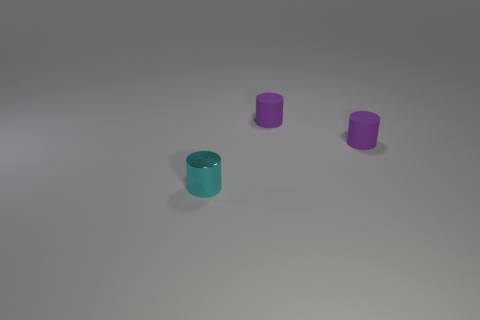What could be the purpose of these objects? The objects might be decorative, like vases, or functional, perhaps canisters or containers of some sort, used for storing items or simply as aesthetic pieces. Do the colors of the objects have any specific meaning? Colors often carry symbolic meanings or are used for organization. The cyan could suggest calmness or cleanliness, and the violet color could imply creativity or luxury, but without more context, it's challenging to determine their intended meaning here. 